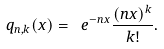Convert formula to latex. <formula><loc_0><loc_0><loc_500><loc_500>q _ { n , k } ( x ) = \ e ^ { - n x } \frac { ( n x ) ^ { k } } { k ! } .</formula> 